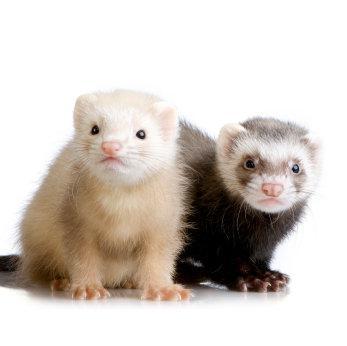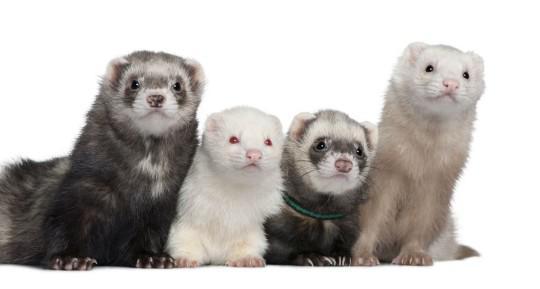The first image is the image on the left, the second image is the image on the right. For the images displayed, is the sentence "An image contains exactly two ferrets, and one has its head over the other ferret's neck area." factually correct? Answer yes or no. No. The first image is the image on the left, the second image is the image on the right. Examine the images to the left and right. Is the description "The right image contains exactly two ferrets." accurate? Answer yes or no. No. 